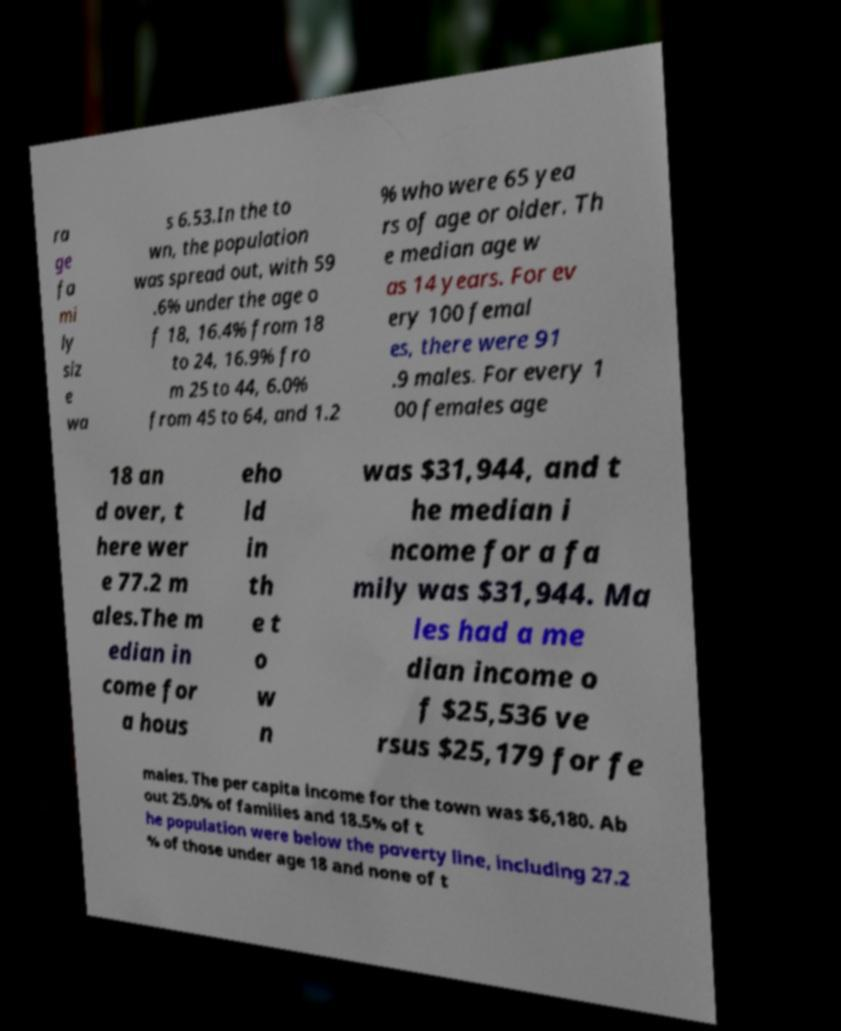Could you extract and type out the text from this image? ra ge fa mi ly siz e wa s 6.53.In the to wn, the population was spread out, with 59 .6% under the age o f 18, 16.4% from 18 to 24, 16.9% fro m 25 to 44, 6.0% from 45 to 64, and 1.2 % who were 65 yea rs of age or older. Th e median age w as 14 years. For ev ery 100 femal es, there were 91 .9 males. For every 1 00 females age 18 an d over, t here wer e 77.2 m ales.The m edian in come for a hous eho ld in th e t o w n was $31,944, and t he median i ncome for a fa mily was $31,944. Ma les had a me dian income o f $25,536 ve rsus $25,179 for fe males. The per capita income for the town was $6,180. Ab out 25.0% of families and 18.5% of t he population were below the poverty line, including 27.2 % of those under age 18 and none of t 